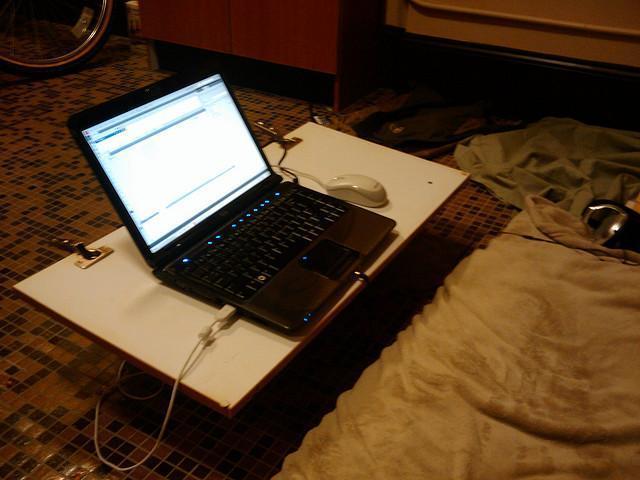How many suitcases have locks on them?
Give a very brief answer. 0. How many black umbrella are there?
Give a very brief answer. 0. 